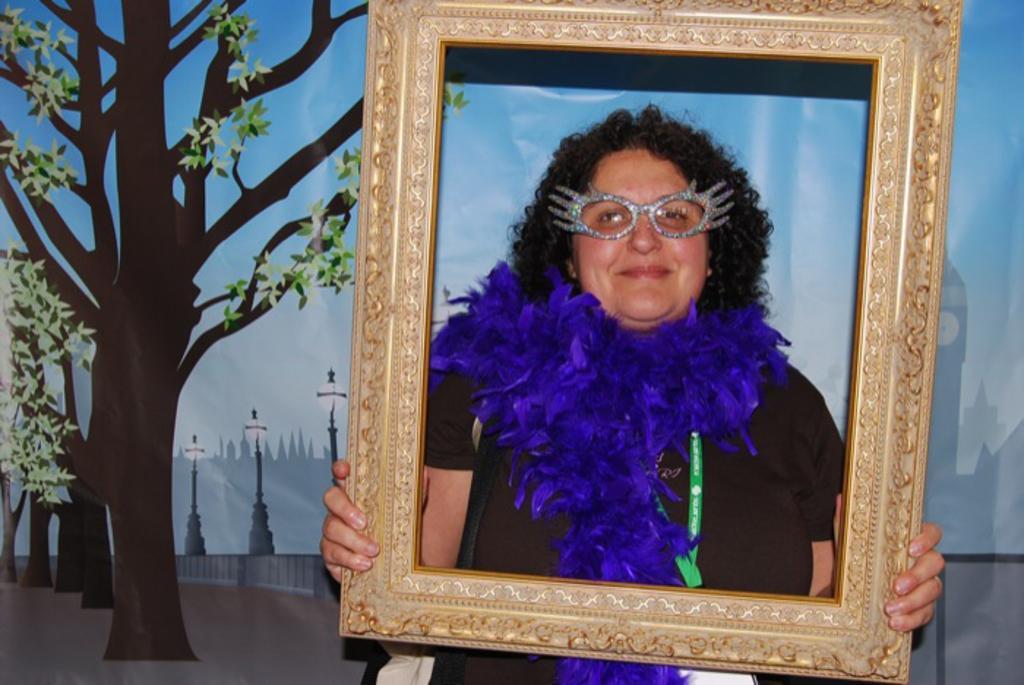Please provide a concise description of this image. There is a woman in a t-shirt, smiling and holding a frame. In the background, there is a banner in which, there are trees, lights attached to the poles, a mountain and there is sky. 